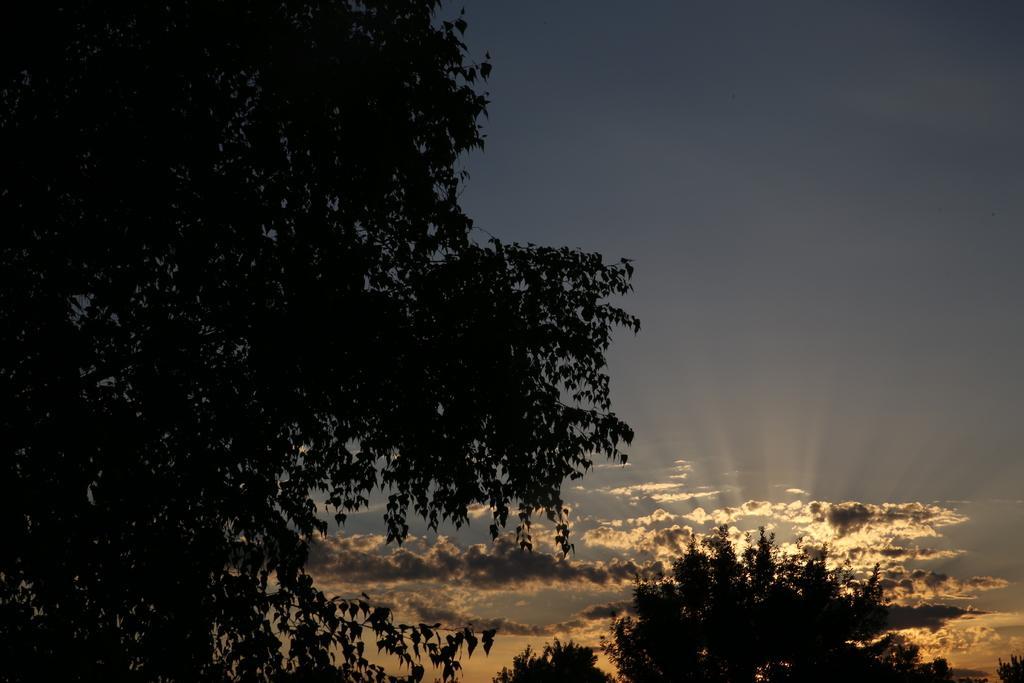How would you summarize this image in a sentence or two? In this image we can see trees. In the background of the image there is sky and clouds. 